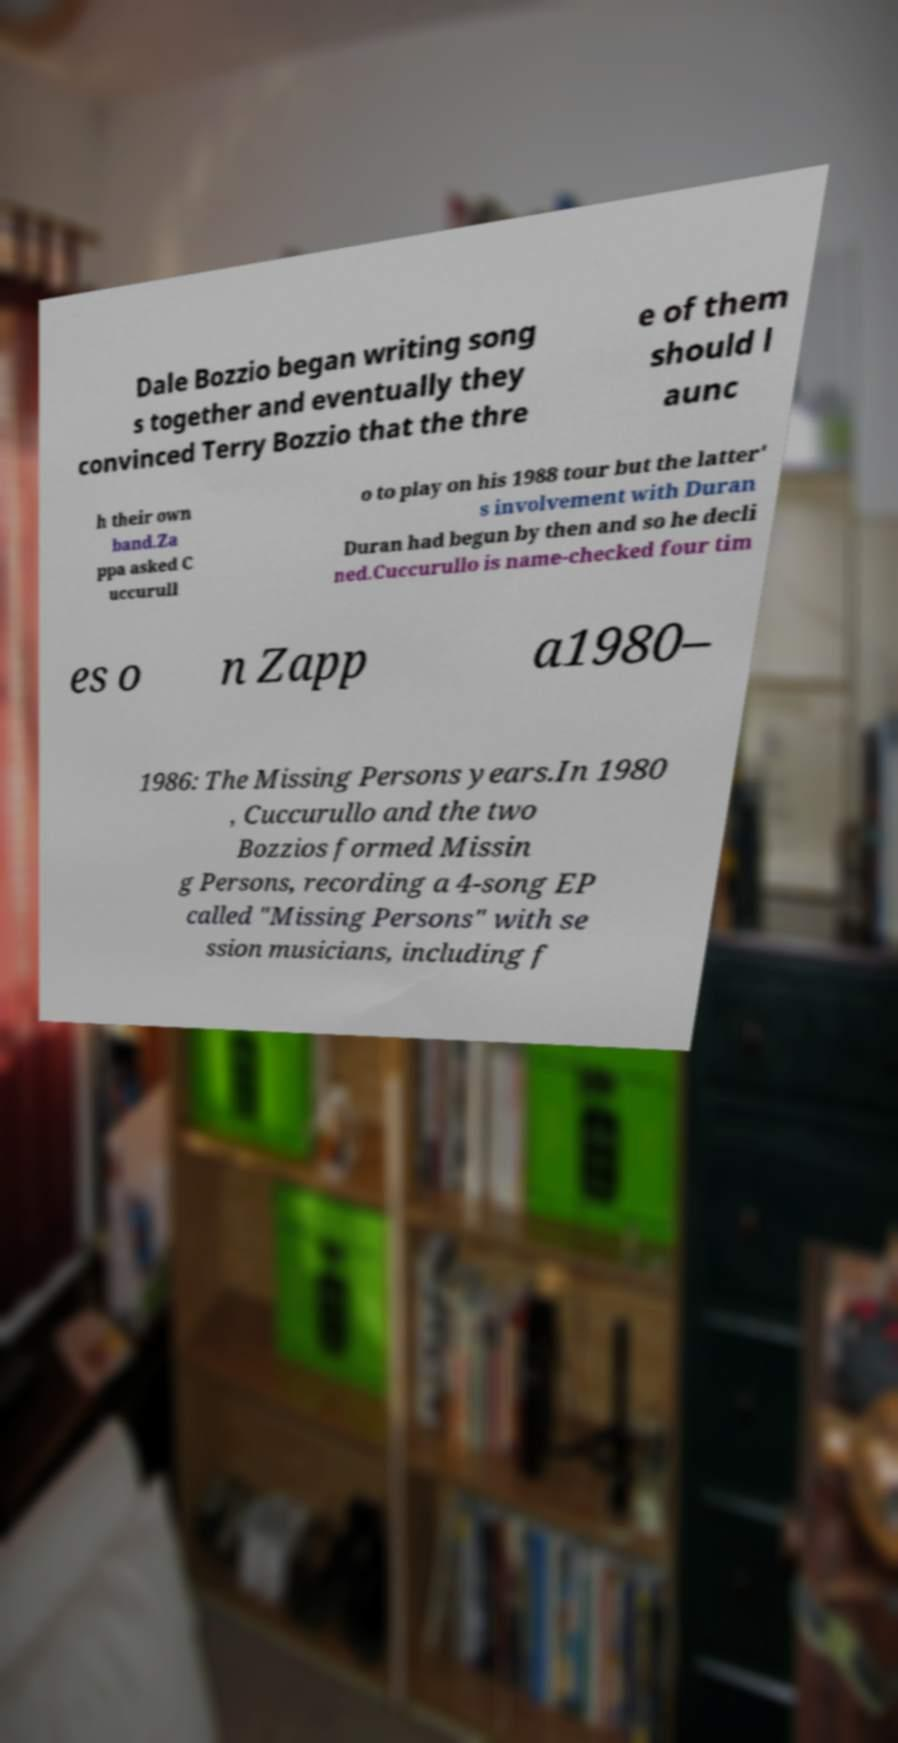There's text embedded in this image that I need extracted. Can you transcribe it verbatim? Certainly! The text in the image reads: 'Dale Bozzio began writing songs together and eventually they convinced Terry Bozzio that the three of them should launch their own band. Zappa asked Cuccurullo to play on his 1988 tour but the latter's involvement with Duran Duran had begun by then and so he declined. Cuccurullo is name-checked four times on Zappa 1980–1986: The Missing Persons years. In 1980, Cuccurullo and the two Bozzios formed Missing Persons, recording a 4-song EP called "Missing Persons" with session musicians, including f' 